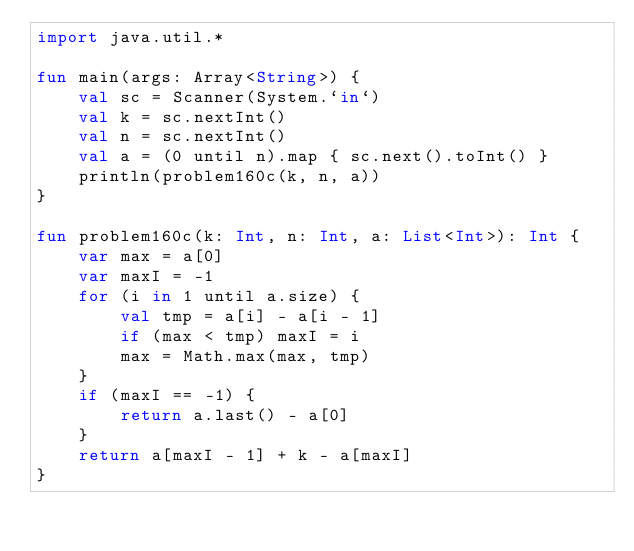<code> <loc_0><loc_0><loc_500><loc_500><_Kotlin_>import java.util.*

fun main(args: Array<String>) {
    val sc = Scanner(System.`in`)
    val k = sc.nextInt()
    val n = sc.nextInt()
    val a = (0 until n).map { sc.next().toInt() }
    println(problem160c(k, n, a))
}

fun problem160c(k: Int, n: Int, a: List<Int>): Int {
    var max = a[0]
    var maxI = -1
    for (i in 1 until a.size) {
        val tmp = a[i] - a[i - 1]
        if (max < tmp) maxI = i
        max = Math.max(max, tmp)
    }
    if (maxI == -1) {
        return a.last() - a[0]
    }
    return a[maxI - 1] + k - a[maxI]
}</code> 